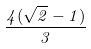<formula> <loc_0><loc_0><loc_500><loc_500>\frac { 4 ( \sqrt { 2 } - 1 ) } { 3 }</formula> 